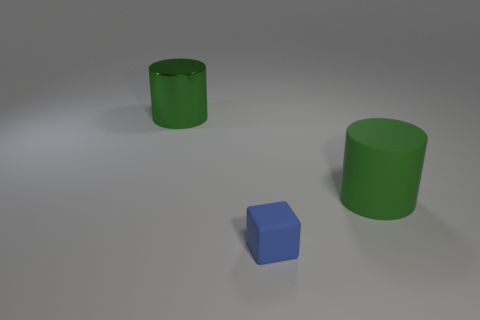Add 3 tiny blue rubber objects. How many objects exist? 6 Subtract all cylinders. How many objects are left? 1 Add 1 purple metallic spheres. How many purple metallic spheres exist? 1 Subtract 0 green balls. How many objects are left? 3 Subtract all cubes. Subtract all rubber cubes. How many objects are left? 1 Add 2 green metal cylinders. How many green metal cylinders are left? 3 